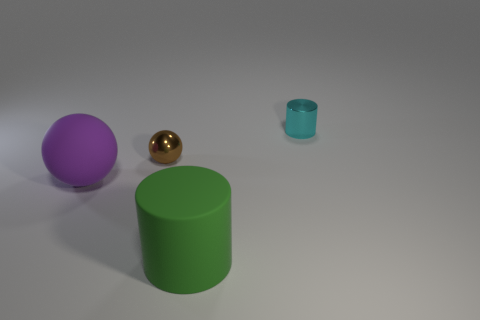There is a cylinder in front of the small thing that is right of the green matte cylinder; are there any rubber spheres behind it?
Offer a terse response. Yes. The object that is right of the tiny sphere and in front of the cyan cylinder has what shape?
Provide a short and direct response. Cylinder. The big thing that is behind the large rubber object in front of the big matte sphere is what color?
Your response must be concise. Purple. There is a cyan object that is behind the big rubber thing that is behind the large object in front of the purple matte sphere; what is its size?
Your answer should be compact. Small. Do the small cyan cylinder and the tiny object that is on the left side of the green object have the same material?
Keep it short and to the point. Yes. There is a cylinder that is the same material as the brown object; what size is it?
Keep it short and to the point. Small. Are there any other small cyan shiny objects of the same shape as the cyan metallic object?
Keep it short and to the point. No. What number of objects are either tiny metal things that are in front of the shiny cylinder or small blue matte cubes?
Your response must be concise. 1. The cyan metallic cylinder has what size?
Provide a short and direct response. Small. How many big things are cyan matte balls or rubber objects?
Give a very brief answer. 2. 